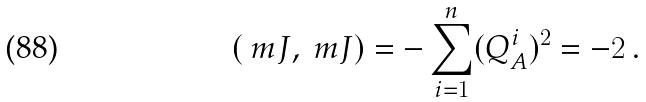<formula> <loc_0><loc_0><loc_500><loc_500>( \ m J , \ m J ) = - \sum _ { i = 1 } ^ { n } ( Q _ { A } ^ { i } ) ^ { 2 } = - 2 \, .</formula> 